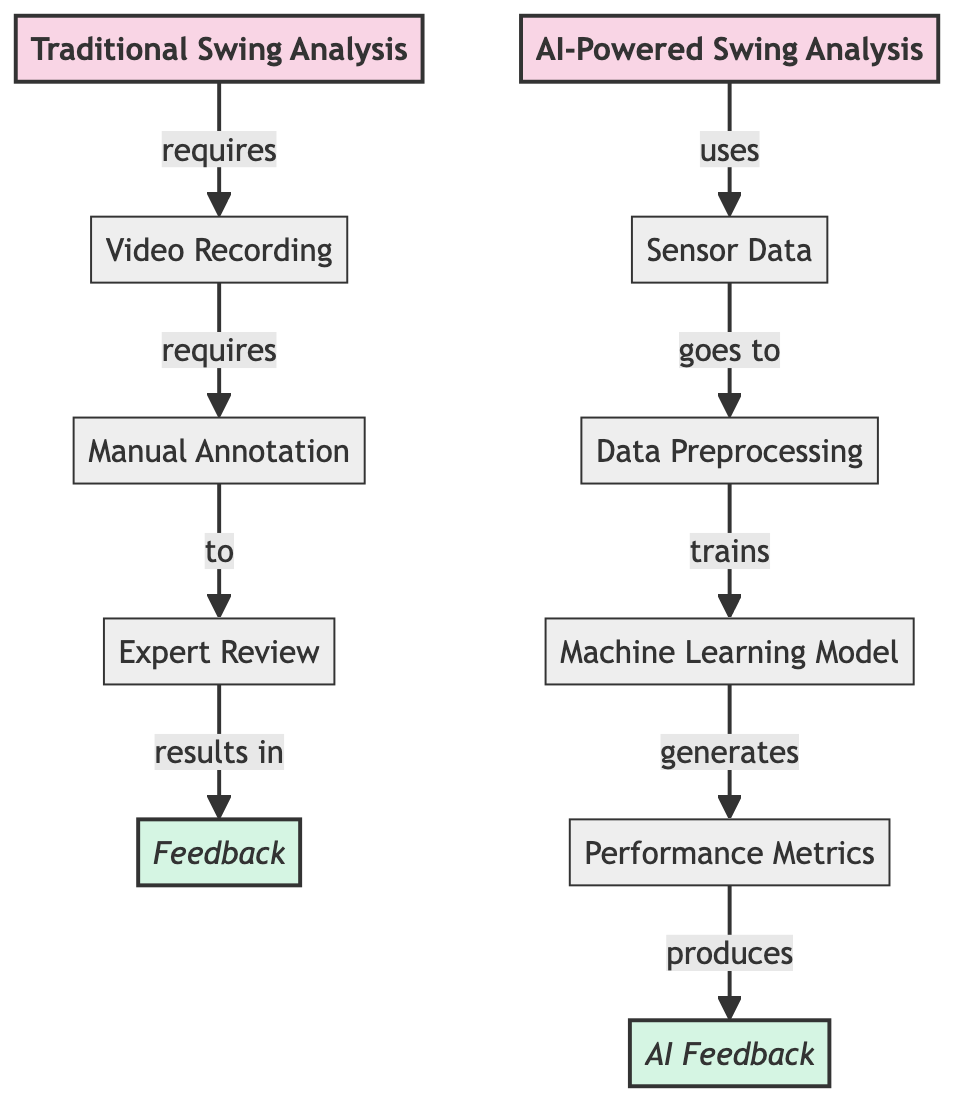What's the first step in Traditional Swing Analysis? The first step is "Video Recording", which is indicated by the direct flow from the category "Traditional Swing Analysis" to the process node labeled "Video Recording".
Answer: Video Recording How many output nodes are there in the diagram? There are two output nodes: "Feedback" and "AI Feedback". This can be counted by identifying the nodes that are categorized as outputs in the diagram.
Answer: 2 What does "Manual Annotation" lead to in Traditional Swing Analysis? "Manual Annotation" leads to "Expert Review", as shown by the directed flow from the "Manual Annotation" node to the "Expert Review" node.
Answer: Expert Review Which process does "Sensor Data" go to in AI-Powered Swing Analysis? "Sensor Data" goes to "Data Preprocessing", as indicated by the direct flow from the node "Sensor Data" to the node "Data Preprocessing".
Answer: Data Preprocessing What is the final output of AI-Powered Swing Analysis? The final output is "AI Feedback", which is generated from the process "Performance Metrics" that follows the machine learning model.
Answer: AI Feedback How does "Expert Review" relate to "Feedback"? "Expert Review" results in "Feedback", showing a direct causal relationship as indicated in the diagram's flow.
Answer: Feedback What step comes after "Data Preprocessing"? The step that comes after "Data Preprocessing" is "Machine Learning Model", as they are connected by a direct flow indicating that the model is trained on the preprocessed data.
Answer: Machine Learning Model What links "Performance Metrics" to its output? "Performance Metrics" generates the output "AI Feedback", making it clear that this is the process that leads directly to producing the feedback in AI-Powered analysis.
Answer: AI Feedback 